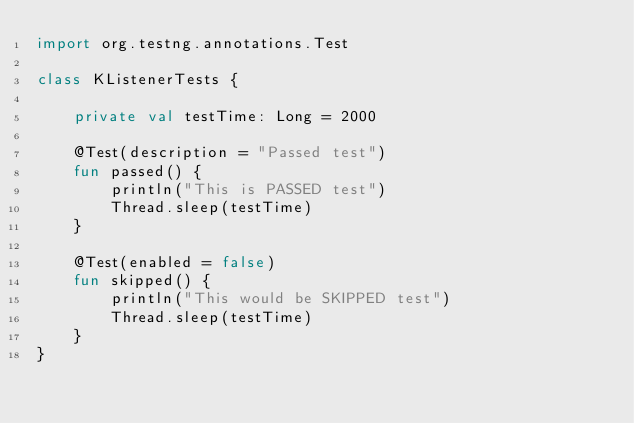<code> <loc_0><loc_0><loc_500><loc_500><_Kotlin_>import org.testng.annotations.Test

class KListenerTests {

    private val testTime: Long = 2000

    @Test(description = "Passed test")
    fun passed() {
        println("This is PASSED test")
        Thread.sleep(testTime)
    }

    @Test(enabled = false)
    fun skipped() {
        println("This would be SKIPPED test")
        Thread.sleep(testTime)
    }
}</code> 